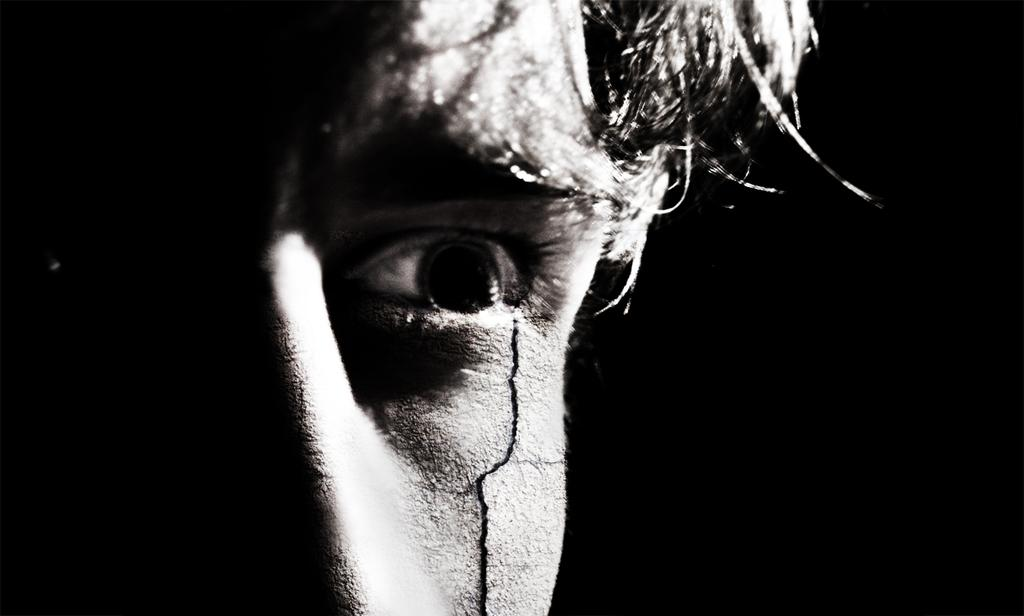What is the color scheme of the image? The image is black and white. What is the main subject of the image? There is a man's face in the image. Can you describe any specific details about the man's face? There is a small crack near the man's eye in the image. How many snakes are wrapped around the man's face in the image? There are no snakes present in the image; it only features a man's face with a small crack near his eye. What type of cherries can be seen growing on the man's face in the image? There are no cherries present in the image; it only features a man's face with a small crack near his eye. 